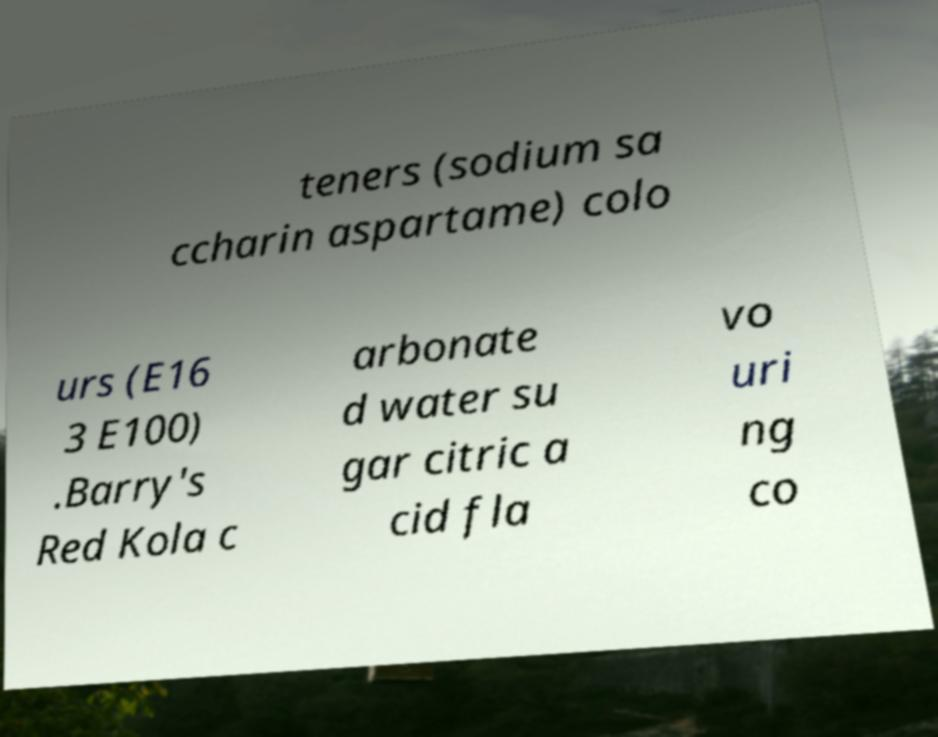Could you extract and type out the text from this image? teners (sodium sa ccharin aspartame) colo urs (E16 3 E100) .Barry's Red Kola c arbonate d water su gar citric a cid fla vo uri ng co 